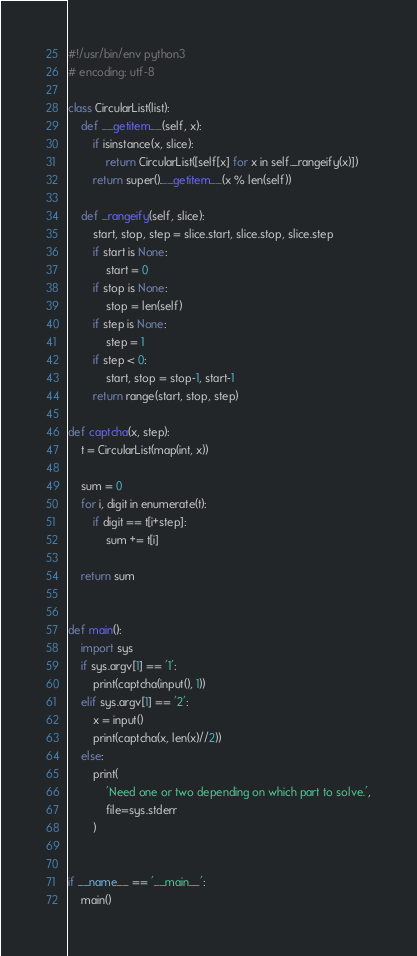<code> <loc_0><loc_0><loc_500><loc_500><_Python_>#!/usr/bin/env python3
# encoding: utf-8

class CircularList(list):
	def __getitem__(self, x):
		if isinstance(x, slice):
			return CircularList([self[x] for x in self._rangeify(x)])
		return super().__getitem__(x % len(self))

	def _rangeify(self, slice):
		start, stop, step = slice.start, slice.stop, slice.step
		if start is None:
			start = 0
		if stop is None:
			stop = len(self)
		if step is None:
			step = 1
		if step < 0:
			start, stop = stop-1, start-1
		return range(start, stop, step)

def captcha(x, step):
	t = CircularList(map(int, x))

	sum = 0
	for i, digit in enumerate(t):
		if digit == t[i+step]:
			sum += t[i]

	return sum


def main():
	import sys
	if sys.argv[1] == '1':
		print(captcha(input(), 1))
	elif sys.argv[1] == '2':
		x = input()
		print(captcha(x, len(x)//2))
	else:
		print(
			'Need one or two depending on which part to solve.',
			file=sys.stderr
		)


if __name__ == '__main__':
	main()
</code> 